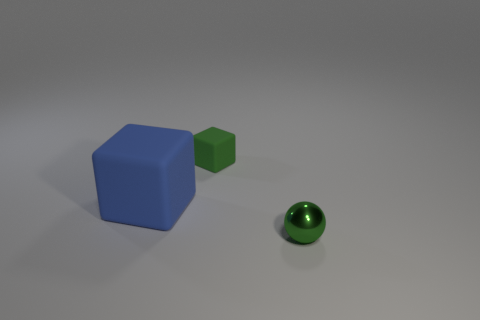Add 2 blue blocks. How many objects exist? 5 Subtract all green cubes. How many cubes are left? 1 Subtract 2 cubes. How many cubes are left? 0 Subtract all blue cubes. Subtract all brown spheres. How many cubes are left? 1 Subtract all blue cylinders. How many green blocks are left? 1 Subtract all red spheres. Subtract all big blue cubes. How many objects are left? 2 Add 1 green balls. How many green balls are left? 2 Add 3 gray rubber objects. How many gray rubber objects exist? 3 Subtract 0 gray cylinders. How many objects are left? 3 Subtract all blocks. How many objects are left? 1 